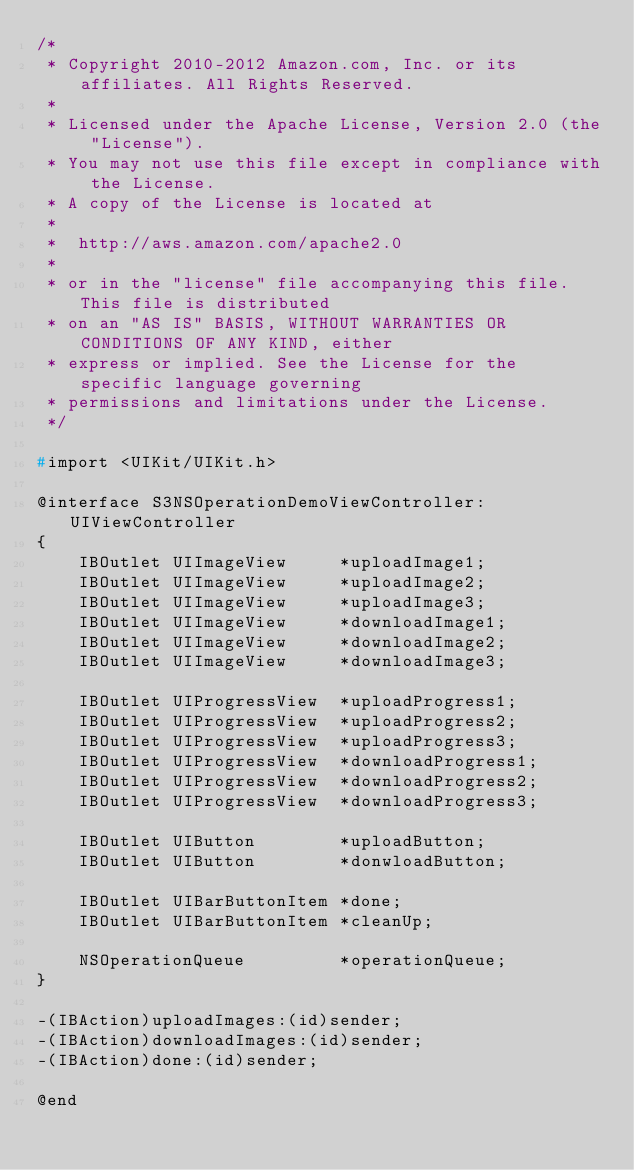<code> <loc_0><loc_0><loc_500><loc_500><_C_>/*
 * Copyright 2010-2012 Amazon.com, Inc. or its affiliates. All Rights Reserved.
 *
 * Licensed under the Apache License, Version 2.0 (the "License").
 * You may not use this file except in compliance with the License.
 * A copy of the License is located at
 *
 *  http://aws.amazon.com/apache2.0
 *
 * or in the "license" file accompanying this file. This file is distributed
 * on an "AS IS" BASIS, WITHOUT WARRANTIES OR CONDITIONS OF ANY KIND, either
 * express or implied. See the License for the specific language governing
 * permissions and limitations under the License.
 */

#import <UIKit/UIKit.h>

@interface S3NSOperationDemoViewController:UIViewController
{
    IBOutlet UIImageView     *uploadImage1;
    IBOutlet UIImageView     *uploadImage2;
    IBOutlet UIImageView     *uploadImage3;
    IBOutlet UIImageView     *downloadImage1;
    IBOutlet UIImageView     *downloadImage2;
    IBOutlet UIImageView     *downloadImage3;

    IBOutlet UIProgressView  *uploadProgress1;
    IBOutlet UIProgressView  *uploadProgress2;
    IBOutlet UIProgressView  *uploadProgress3;
    IBOutlet UIProgressView  *downloadProgress1;
    IBOutlet UIProgressView  *downloadProgress2;
    IBOutlet UIProgressView  *downloadProgress3;

    IBOutlet UIButton        *uploadButton;
    IBOutlet UIButton        *donwloadButton;

    IBOutlet UIBarButtonItem *done;
    IBOutlet UIBarButtonItem *cleanUp;

    NSOperationQueue         *operationQueue;
}

-(IBAction)uploadImages:(id)sender;
-(IBAction)downloadImages:(id)sender;
-(IBAction)done:(id)sender;

@end
</code> 